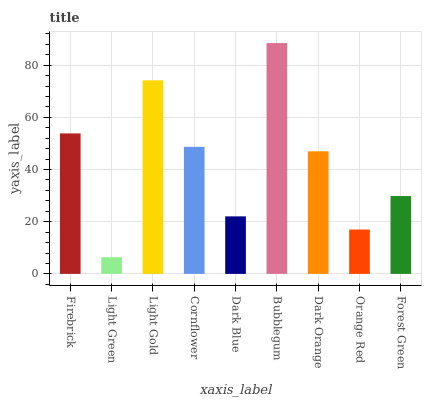Is Light Green the minimum?
Answer yes or no. Yes. Is Bubblegum the maximum?
Answer yes or no. Yes. Is Light Gold the minimum?
Answer yes or no. No. Is Light Gold the maximum?
Answer yes or no. No. Is Light Gold greater than Light Green?
Answer yes or no. Yes. Is Light Green less than Light Gold?
Answer yes or no. Yes. Is Light Green greater than Light Gold?
Answer yes or no. No. Is Light Gold less than Light Green?
Answer yes or no. No. Is Dark Orange the high median?
Answer yes or no. Yes. Is Dark Orange the low median?
Answer yes or no. Yes. Is Forest Green the high median?
Answer yes or no. No. Is Forest Green the low median?
Answer yes or no. No. 